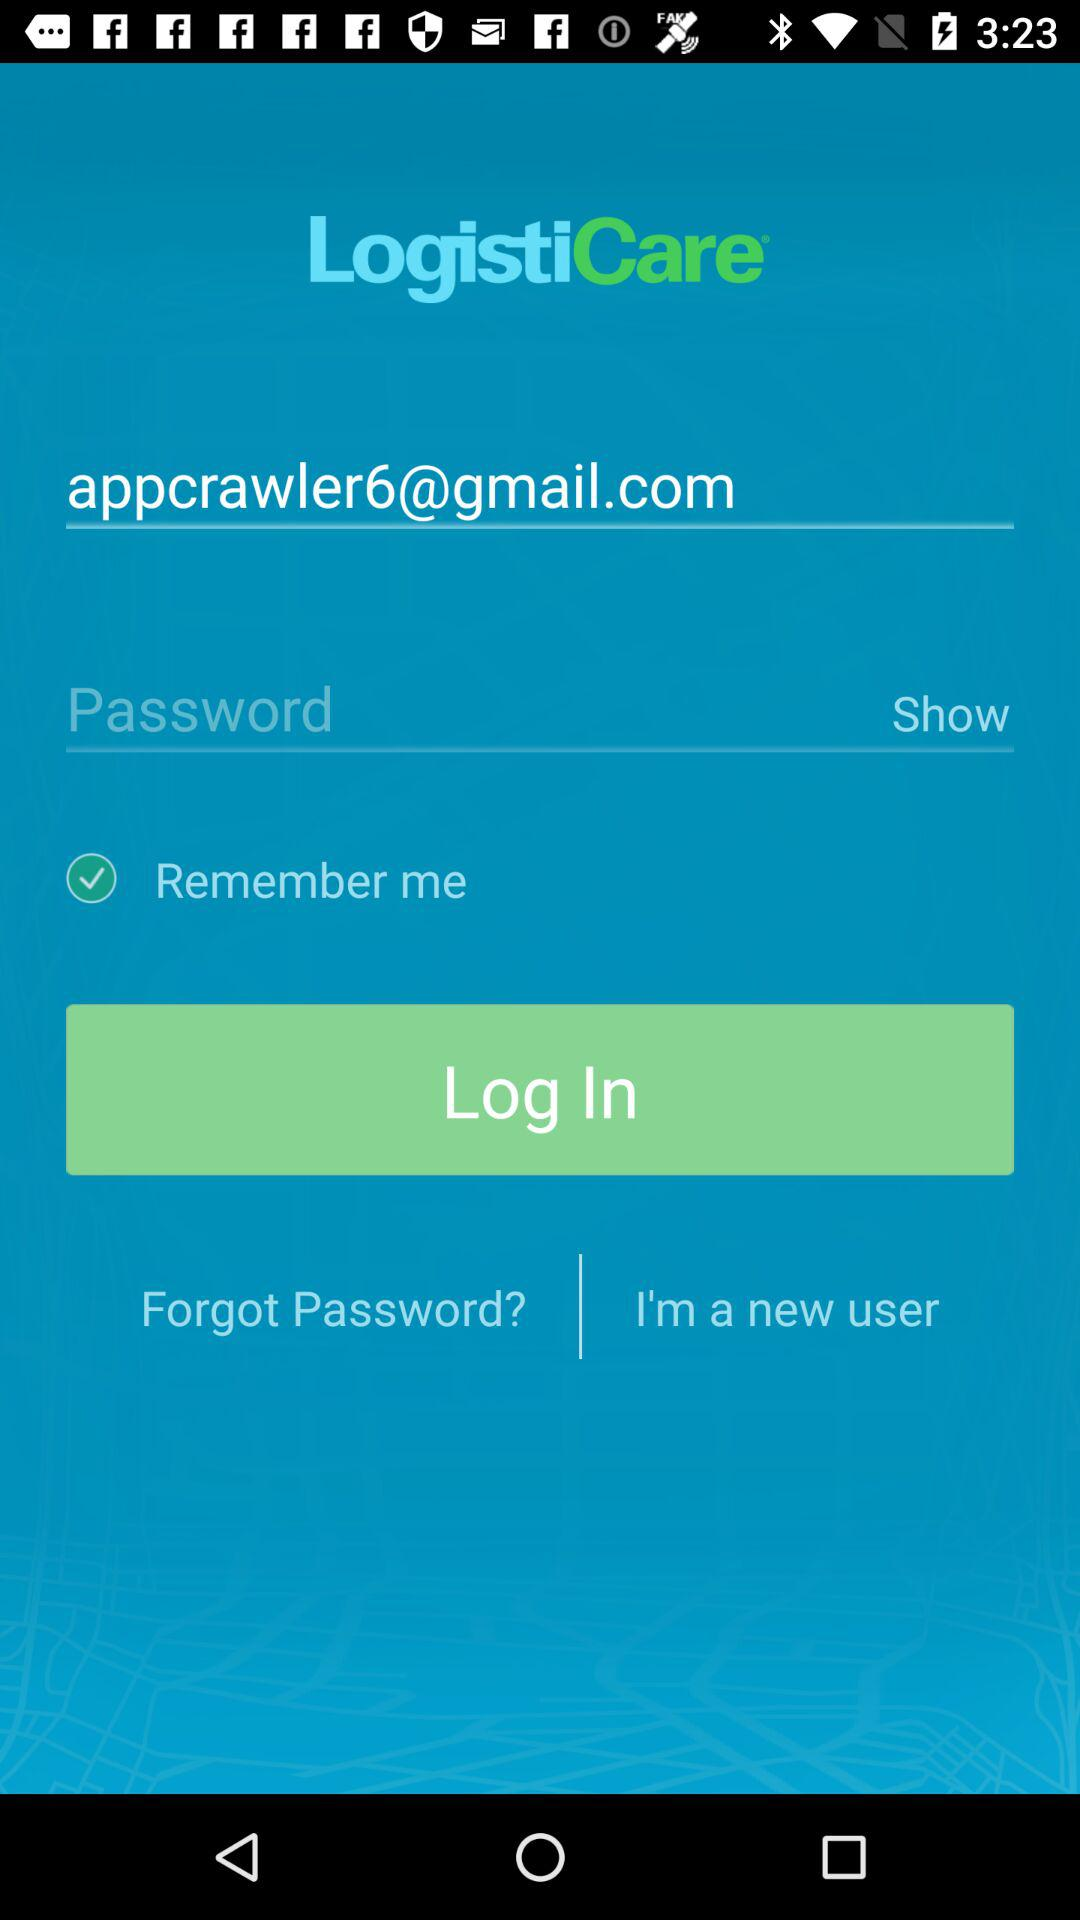What option is checked? The checked option is "Remember me". 